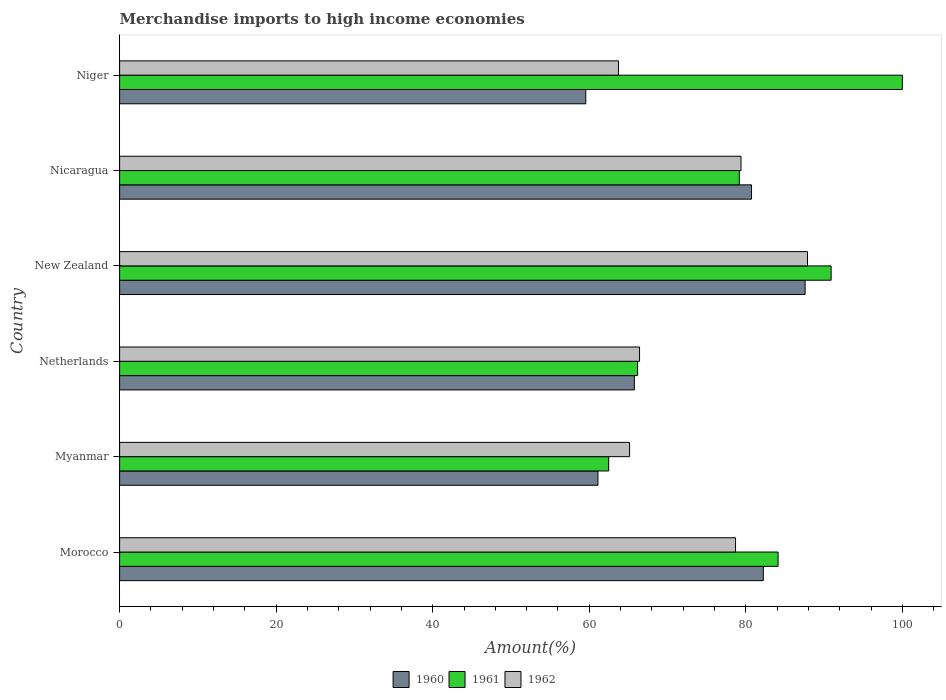How many different coloured bars are there?
Give a very brief answer. 3. Are the number of bars per tick equal to the number of legend labels?
Provide a succinct answer. Yes. How many bars are there on the 5th tick from the top?
Make the answer very short. 3. What is the label of the 2nd group of bars from the top?
Provide a succinct answer. Nicaragua. In how many cases, is the number of bars for a given country not equal to the number of legend labels?
Your answer should be compact. 0. What is the percentage of amount earned from merchandise imports in 1961 in Netherlands?
Make the answer very short. 66.17. Across all countries, what is the maximum percentage of amount earned from merchandise imports in 1960?
Provide a short and direct response. 87.58. Across all countries, what is the minimum percentage of amount earned from merchandise imports in 1961?
Give a very brief answer. 62.48. In which country was the percentage of amount earned from merchandise imports in 1960 maximum?
Ensure brevity in your answer.  New Zealand. In which country was the percentage of amount earned from merchandise imports in 1962 minimum?
Make the answer very short. Niger. What is the total percentage of amount earned from merchandise imports in 1961 in the graph?
Make the answer very short. 482.85. What is the difference between the percentage of amount earned from merchandise imports in 1962 in Morocco and that in Myanmar?
Provide a succinct answer. 13.54. What is the difference between the percentage of amount earned from merchandise imports in 1960 in New Zealand and the percentage of amount earned from merchandise imports in 1962 in Myanmar?
Give a very brief answer. 22.42. What is the average percentage of amount earned from merchandise imports in 1962 per country?
Ensure brevity in your answer.  73.55. What is the difference between the percentage of amount earned from merchandise imports in 1960 and percentage of amount earned from merchandise imports in 1961 in Netherlands?
Ensure brevity in your answer.  -0.41. In how many countries, is the percentage of amount earned from merchandise imports in 1962 greater than 44 %?
Provide a short and direct response. 6. What is the ratio of the percentage of amount earned from merchandise imports in 1962 in Myanmar to that in New Zealand?
Your response must be concise. 0.74. Is the percentage of amount earned from merchandise imports in 1962 in Netherlands less than that in New Zealand?
Offer a terse response. Yes. Is the difference between the percentage of amount earned from merchandise imports in 1960 in Myanmar and New Zealand greater than the difference between the percentage of amount earned from merchandise imports in 1961 in Myanmar and New Zealand?
Keep it short and to the point. Yes. What is the difference between the highest and the second highest percentage of amount earned from merchandise imports in 1960?
Provide a succinct answer. 5.34. What is the difference between the highest and the lowest percentage of amount earned from merchandise imports in 1960?
Make the answer very short. 28.02. In how many countries, is the percentage of amount earned from merchandise imports in 1962 greater than the average percentage of amount earned from merchandise imports in 1962 taken over all countries?
Your answer should be very brief. 3. Is the sum of the percentage of amount earned from merchandise imports in 1962 in Myanmar and Netherlands greater than the maximum percentage of amount earned from merchandise imports in 1961 across all countries?
Offer a very short reply. Yes. Is it the case that in every country, the sum of the percentage of amount earned from merchandise imports in 1960 and percentage of amount earned from merchandise imports in 1961 is greater than the percentage of amount earned from merchandise imports in 1962?
Provide a short and direct response. Yes. Are all the bars in the graph horizontal?
Make the answer very short. Yes. What is the difference between two consecutive major ticks on the X-axis?
Your answer should be very brief. 20. Are the values on the major ticks of X-axis written in scientific E-notation?
Your answer should be very brief. No. Does the graph contain grids?
Your response must be concise. No. How are the legend labels stacked?
Keep it short and to the point. Horizontal. What is the title of the graph?
Make the answer very short. Merchandise imports to high income economies. What is the label or title of the X-axis?
Offer a terse response. Amount(%). What is the Amount(%) in 1960 in Morocco?
Your response must be concise. 82.24. What is the Amount(%) in 1961 in Morocco?
Keep it short and to the point. 84.12. What is the Amount(%) of 1962 in Morocco?
Offer a terse response. 78.69. What is the Amount(%) of 1960 in Myanmar?
Your response must be concise. 61.11. What is the Amount(%) of 1961 in Myanmar?
Provide a succinct answer. 62.48. What is the Amount(%) in 1962 in Myanmar?
Offer a terse response. 65.15. What is the Amount(%) in 1960 in Netherlands?
Your response must be concise. 65.76. What is the Amount(%) in 1961 in Netherlands?
Provide a short and direct response. 66.17. What is the Amount(%) of 1962 in Netherlands?
Keep it short and to the point. 66.42. What is the Amount(%) in 1960 in New Zealand?
Give a very brief answer. 87.58. What is the Amount(%) of 1961 in New Zealand?
Ensure brevity in your answer.  90.9. What is the Amount(%) of 1962 in New Zealand?
Give a very brief answer. 87.88. What is the Amount(%) of 1960 in Nicaragua?
Ensure brevity in your answer.  80.73. What is the Amount(%) of 1961 in Nicaragua?
Keep it short and to the point. 79.17. What is the Amount(%) in 1962 in Nicaragua?
Your answer should be compact. 79.39. What is the Amount(%) of 1960 in Niger?
Make the answer very short. 59.56. What is the Amount(%) of 1961 in Niger?
Ensure brevity in your answer.  100. What is the Amount(%) of 1962 in Niger?
Make the answer very short. 63.74. Across all countries, what is the maximum Amount(%) in 1960?
Your answer should be very brief. 87.58. Across all countries, what is the maximum Amount(%) in 1962?
Make the answer very short. 87.88. Across all countries, what is the minimum Amount(%) in 1960?
Provide a succinct answer. 59.56. Across all countries, what is the minimum Amount(%) in 1961?
Keep it short and to the point. 62.48. Across all countries, what is the minimum Amount(%) in 1962?
Provide a short and direct response. 63.74. What is the total Amount(%) of 1960 in the graph?
Give a very brief answer. 436.97. What is the total Amount(%) of 1961 in the graph?
Provide a succinct answer. 482.85. What is the total Amount(%) in 1962 in the graph?
Your response must be concise. 441.27. What is the difference between the Amount(%) of 1960 in Morocco and that in Myanmar?
Ensure brevity in your answer.  21.12. What is the difference between the Amount(%) in 1961 in Morocco and that in Myanmar?
Your response must be concise. 21.64. What is the difference between the Amount(%) of 1962 in Morocco and that in Myanmar?
Provide a succinct answer. 13.54. What is the difference between the Amount(%) of 1960 in Morocco and that in Netherlands?
Your response must be concise. 16.48. What is the difference between the Amount(%) in 1961 in Morocco and that in Netherlands?
Provide a short and direct response. 17.95. What is the difference between the Amount(%) of 1962 in Morocco and that in Netherlands?
Provide a short and direct response. 12.27. What is the difference between the Amount(%) in 1960 in Morocco and that in New Zealand?
Your answer should be very brief. -5.34. What is the difference between the Amount(%) in 1961 in Morocco and that in New Zealand?
Provide a succinct answer. -6.78. What is the difference between the Amount(%) of 1962 in Morocco and that in New Zealand?
Your answer should be very brief. -9.19. What is the difference between the Amount(%) of 1960 in Morocco and that in Nicaragua?
Provide a succinct answer. 1.5. What is the difference between the Amount(%) of 1961 in Morocco and that in Nicaragua?
Offer a very short reply. 4.96. What is the difference between the Amount(%) of 1962 in Morocco and that in Nicaragua?
Provide a short and direct response. -0.7. What is the difference between the Amount(%) in 1960 in Morocco and that in Niger?
Your response must be concise. 22.68. What is the difference between the Amount(%) of 1961 in Morocco and that in Niger?
Offer a very short reply. -15.88. What is the difference between the Amount(%) in 1962 in Morocco and that in Niger?
Keep it short and to the point. 14.95. What is the difference between the Amount(%) in 1960 in Myanmar and that in Netherlands?
Offer a very short reply. -4.65. What is the difference between the Amount(%) of 1961 in Myanmar and that in Netherlands?
Ensure brevity in your answer.  -3.69. What is the difference between the Amount(%) in 1962 in Myanmar and that in Netherlands?
Ensure brevity in your answer.  -1.27. What is the difference between the Amount(%) in 1960 in Myanmar and that in New Zealand?
Offer a very short reply. -26.47. What is the difference between the Amount(%) of 1961 in Myanmar and that in New Zealand?
Provide a succinct answer. -28.42. What is the difference between the Amount(%) in 1962 in Myanmar and that in New Zealand?
Your answer should be compact. -22.73. What is the difference between the Amount(%) in 1960 in Myanmar and that in Nicaragua?
Keep it short and to the point. -19.62. What is the difference between the Amount(%) in 1961 in Myanmar and that in Nicaragua?
Keep it short and to the point. -16.68. What is the difference between the Amount(%) in 1962 in Myanmar and that in Nicaragua?
Provide a short and direct response. -14.23. What is the difference between the Amount(%) of 1960 in Myanmar and that in Niger?
Ensure brevity in your answer.  1.55. What is the difference between the Amount(%) of 1961 in Myanmar and that in Niger?
Keep it short and to the point. -37.52. What is the difference between the Amount(%) in 1962 in Myanmar and that in Niger?
Keep it short and to the point. 1.42. What is the difference between the Amount(%) in 1960 in Netherlands and that in New Zealand?
Ensure brevity in your answer.  -21.82. What is the difference between the Amount(%) in 1961 in Netherlands and that in New Zealand?
Your answer should be very brief. -24.73. What is the difference between the Amount(%) in 1962 in Netherlands and that in New Zealand?
Make the answer very short. -21.46. What is the difference between the Amount(%) in 1960 in Netherlands and that in Nicaragua?
Your response must be concise. -14.97. What is the difference between the Amount(%) in 1961 in Netherlands and that in Nicaragua?
Your answer should be compact. -12.99. What is the difference between the Amount(%) of 1962 in Netherlands and that in Nicaragua?
Offer a terse response. -12.96. What is the difference between the Amount(%) of 1960 in Netherlands and that in Niger?
Your response must be concise. 6.2. What is the difference between the Amount(%) in 1961 in Netherlands and that in Niger?
Provide a short and direct response. -33.83. What is the difference between the Amount(%) in 1962 in Netherlands and that in Niger?
Provide a short and direct response. 2.69. What is the difference between the Amount(%) in 1960 in New Zealand and that in Nicaragua?
Your answer should be compact. 6.85. What is the difference between the Amount(%) in 1961 in New Zealand and that in Nicaragua?
Your answer should be very brief. 11.73. What is the difference between the Amount(%) of 1962 in New Zealand and that in Nicaragua?
Your answer should be very brief. 8.49. What is the difference between the Amount(%) of 1960 in New Zealand and that in Niger?
Make the answer very short. 28.02. What is the difference between the Amount(%) of 1961 in New Zealand and that in Niger?
Offer a terse response. -9.1. What is the difference between the Amount(%) of 1962 in New Zealand and that in Niger?
Make the answer very short. 24.15. What is the difference between the Amount(%) in 1960 in Nicaragua and that in Niger?
Give a very brief answer. 21.17. What is the difference between the Amount(%) of 1961 in Nicaragua and that in Niger?
Offer a very short reply. -20.83. What is the difference between the Amount(%) in 1962 in Nicaragua and that in Niger?
Give a very brief answer. 15.65. What is the difference between the Amount(%) of 1960 in Morocco and the Amount(%) of 1961 in Myanmar?
Offer a very short reply. 19.75. What is the difference between the Amount(%) of 1960 in Morocco and the Amount(%) of 1962 in Myanmar?
Offer a very short reply. 17.08. What is the difference between the Amount(%) of 1961 in Morocco and the Amount(%) of 1962 in Myanmar?
Give a very brief answer. 18.97. What is the difference between the Amount(%) of 1960 in Morocco and the Amount(%) of 1961 in Netherlands?
Offer a very short reply. 16.06. What is the difference between the Amount(%) in 1960 in Morocco and the Amount(%) in 1962 in Netherlands?
Offer a terse response. 15.81. What is the difference between the Amount(%) in 1961 in Morocco and the Amount(%) in 1962 in Netherlands?
Provide a short and direct response. 17.7. What is the difference between the Amount(%) in 1960 in Morocco and the Amount(%) in 1961 in New Zealand?
Your answer should be compact. -8.66. What is the difference between the Amount(%) in 1960 in Morocco and the Amount(%) in 1962 in New Zealand?
Give a very brief answer. -5.65. What is the difference between the Amount(%) of 1961 in Morocco and the Amount(%) of 1962 in New Zealand?
Offer a terse response. -3.76. What is the difference between the Amount(%) of 1960 in Morocco and the Amount(%) of 1961 in Nicaragua?
Ensure brevity in your answer.  3.07. What is the difference between the Amount(%) in 1960 in Morocco and the Amount(%) in 1962 in Nicaragua?
Offer a very short reply. 2.85. What is the difference between the Amount(%) in 1961 in Morocco and the Amount(%) in 1962 in Nicaragua?
Offer a very short reply. 4.74. What is the difference between the Amount(%) of 1960 in Morocco and the Amount(%) of 1961 in Niger?
Offer a very short reply. -17.76. What is the difference between the Amount(%) in 1960 in Morocco and the Amount(%) in 1962 in Niger?
Your answer should be very brief. 18.5. What is the difference between the Amount(%) of 1961 in Morocco and the Amount(%) of 1962 in Niger?
Ensure brevity in your answer.  20.39. What is the difference between the Amount(%) in 1960 in Myanmar and the Amount(%) in 1961 in Netherlands?
Give a very brief answer. -5.06. What is the difference between the Amount(%) in 1960 in Myanmar and the Amount(%) in 1962 in Netherlands?
Your answer should be very brief. -5.31. What is the difference between the Amount(%) of 1961 in Myanmar and the Amount(%) of 1962 in Netherlands?
Ensure brevity in your answer.  -3.94. What is the difference between the Amount(%) of 1960 in Myanmar and the Amount(%) of 1961 in New Zealand?
Your answer should be very brief. -29.79. What is the difference between the Amount(%) in 1960 in Myanmar and the Amount(%) in 1962 in New Zealand?
Offer a terse response. -26.77. What is the difference between the Amount(%) in 1961 in Myanmar and the Amount(%) in 1962 in New Zealand?
Ensure brevity in your answer.  -25.4. What is the difference between the Amount(%) in 1960 in Myanmar and the Amount(%) in 1961 in Nicaragua?
Your response must be concise. -18.06. What is the difference between the Amount(%) of 1960 in Myanmar and the Amount(%) of 1962 in Nicaragua?
Ensure brevity in your answer.  -18.28. What is the difference between the Amount(%) in 1961 in Myanmar and the Amount(%) in 1962 in Nicaragua?
Offer a terse response. -16.91. What is the difference between the Amount(%) in 1960 in Myanmar and the Amount(%) in 1961 in Niger?
Your answer should be compact. -38.89. What is the difference between the Amount(%) of 1960 in Myanmar and the Amount(%) of 1962 in Niger?
Your answer should be very brief. -2.63. What is the difference between the Amount(%) of 1961 in Myanmar and the Amount(%) of 1962 in Niger?
Your response must be concise. -1.25. What is the difference between the Amount(%) in 1960 in Netherlands and the Amount(%) in 1961 in New Zealand?
Your response must be concise. -25.14. What is the difference between the Amount(%) in 1960 in Netherlands and the Amount(%) in 1962 in New Zealand?
Provide a succinct answer. -22.12. What is the difference between the Amount(%) of 1961 in Netherlands and the Amount(%) of 1962 in New Zealand?
Give a very brief answer. -21.71. What is the difference between the Amount(%) of 1960 in Netherlands and the Amount(%) of 1961 in Nicaragua?
Give a very brief answer. -13.41. What is the difference between the Amount(%) in 1960 in Netherlands and the Amount(%) in 1962 in Nicaragua?
Offer a terse response. -13.63. What is the difference between the Amount(%) in 1961 in Netherlands and the Amount(%) in 1962 in Nicaragua?
Make the answer very short. -13.21. What is the difference between the Amount(%) in 1960 in Netherlands and the Amount(%) in 1961 in Niger?
Your response must be concise. -34.24. What is the difference between the Amount(%) of 1960 in Netherlands and the Amount(%) of 1962 in Niger?
Your response must be concise. 2.02. What is the difference between the Amount(%) in 1961 in Netherlands and the Amount(%) in 1962 in Niger?
Offer a very short reply. 2.44. What is the difference between the Amount(%) of 1960 in New Zealand and the Amount(%) of 1961 in Nicaragua?
Provide a succinct answer. 8.41. What is the difference between the Amount(%) of 1960 in New Zealand and the Amount(%) of 1962 in Nicaragua?
Provide a short and direct response. 8.19. What is the difference between the Amount(%) of 1961 in New Zealand and the Amount(%) of 1962 in Nicaragua?
Provide a succinct answer. 11.51. What is the difference between the Amount(%) in 1960 in New Zealand and the Amount(%) in 1961 in Niger?
Give a very brief answer. -12.42. What is the difference between the Amount(%) in 1960 in New Zealand and the Amount(%) in 1962 in Niger?
Make the answer very short. 23.84. What is the difference between the Amount(%) of 1961 in New Zealand and the Amount(%) of 1962 in Niger?
Provide a succinct answer. 27.16. What is the difference between the Amount(%) in 1960 in Nicaragua and the Amount(%) in 1961 in Niger?
Offer a very short reply. -19.27. What is the difference between the Amount(%) of 1960 in Nicaragua and the Amount(%) of 1962 in Niger?
Provide a short and direct response. 17. What is the difference between the Amount(%) of 1961 in Nicaragua and the Amount(%) of 1962 in Niger?
Make the answer very short. 15.43. What is the average Amount(%) of 1960 per country?
Your response must be concise. 72.83. What is the average Amount(%) of 1961 per country?
Your answer should be compact. 80.47. What is the average Amount(%) of 1962 per country?
Provide a succinct answer. 73.55. What is the difference between the Amount(%) of 1960 and Amount(%) of 1961 in Morocco?
Offer a terse response. -1.89. What is the difference between the Amount(%) in 1960 and Amount(%) in 1962 in Morocco?
Your response must be concise. 3.54. What is the difference between the Amount(%) of 1961 and Amount(%) of 1962 in Morocco?
Make the answer very short. 5.43. What is the difference between the Amount(%) of 1960 and Amount(%) of 1961 in Myanmar?
Provide a succinct answer. -1.37. What is the difference between the Amount(%) of 1960 and Amount(%) of 1962 in Myanmar?
Your response must be concise. -4.04. What is the difference between the Amount(%) in 1961 and Amount(%) in 1962 in Myanmar?
Give a very brief answer. -2.67. What is the difference between the Amount(%) in 1960 and Amount(%) in 1961 in Netherlands?
Offer a very short reply. -0.41. What is the difference between the Amount(%) in 1960 and Amount(%) in 1962 in Netherlands?
Offer a very short reply. -0.66. What is the difference between the Amount(%) in 1961 and Amount(%) in 1962 in Netherlands?
Your response must be concise. -0.25. What is the difference between the Amount(%) of 1960 and Amount(%) of 1961 in New Zealand?
Your answer should be compact. -3.32. What is the difference between the Amount(%) in 1960 and Amount(%) in 1962 in New Zealand?
Your answer should be compact. -0.3. What is the difference between the Amount(%) of 1961 and Amount(%) of 1962 in New Zealand?
Your response must be concise. 3.02. What is the difference between the Amount(%) in 1960 and Amount(%) in 1961 in Nicaragua?
Provide a short and direct response. 1.56. What is the difference between the Amount(%) in 1960 and Amount(%) in 1962 in Nicaragua?
Offer a very short reply. 1.34. What is the difference between the Amount(%) in 1961 and Amount(%) in 1962 in Nicaragua?
Offer a terse response. -0.22. What is the difference between the Amount(%) of 1960 and Amount(%) of 1961 in Niger?
Your response must be concise. -40.44. What is the difference between the Amount(%) of 1960 and Amount(%) of 1962 in Niger?
Offer a very short reply. -4.18. What is the difference between the Amount(%) of 1961 and Amount(%) of 1962 in Niger?
Give a very brief answer. 36.26. What is the ratio of the Amount(%) of 1960 in Morocco to that in Myanmar?
Keep it short and to the point. 1.35. What is the ratio of the Amount(%) in 1961 in Morocco to that in Myanmar?
Your answer should be very brief. 1.35. What is the ratio of the Amount(%) in 1962 in Morocco to that in Myanmar?
Give a very brief answer. 1.21. What is the ratio of the Amount(%) of 1960 in Morocco to that in Netherlands?
Make the answer very short. 1.25. What is the ratio of the Amount(%) in 1961 in Morocco to that in Netherlands?
Ensure brevity in your answer.  1.27. What is the ratio of the Amount(%) of 1962 in Morocco to that in Netherlands?
Offer a terse response. 1.18. What is the ratio of the Amount(%) in 1960 in Morocco to that in New Zealand?
Provide a succinct answer. 0.94. What is the ratio of the Amount(%) in 1961 in Morocco to that in New Zealand?
Give a very brief answer. 0.93. What is the ratio of the Amount(%) of 1962 in Morocco to that in New Zealand?
Offer a very short reply. 0.9. What is the ratio of the Amount(%) of 1960 in Morocco to that in Nicaragua?
Your answer should be very brief. 1.02. What is the ratio of the Amount(%) in 1961 in Morocco to that in Nicaragua?
Offer a very short reply. 1.06. What is the ratio of the Amount(%) in 1960 in Morocco to that in Niger?
Your response must be concise. 1.38. What is the ratio of the Amount(%) in 1961 in Morocco to that in Niger?
Provide a short and direct response. 0.84. What is the ratio of the Amount(%) of 1962 in Morocco to that in Niger?
Offer a very short reply. 1.23. What is the ratio of the Amount(%) in 1960 in Myanmar to that in Netherlands?
Offer a very short reply. 0.93. What is the ratio of the Amount(%) of 1961 in Myanmar to that in Netherlands?
Offer a very short reply. 0.94. What is the ratio of the Amount(%) in 1962 in Myanmar to that in Netherlands?
Offer a very short reply. 0.98. What is the ratio of the Amount(%) in 1960 in Myanmar to that in New Zealand?
Keep it short and to the point. 0.7. What is the ratio of the Amount(%) of 1961 in Myanmar to that in New Zealand?
Provide a short and direct response. 0.69. What is the ratio of the Amount(%) of 1962 in Myanmar to that in New Zealand?
Keep it short and to the point. 0.74. What is the ratio of the Amount(%) in 1960 in Myanmar to that in Nicaragua?
Make the answer very short. 0.76. What is the ratio of the Amount(%) of 1961 in Myanmar to that in Nicaragua?
Provide a short and direct response. 0.79. What is the ratio of the Amount(%) in 1962 in Myanmar to that in Nicaragua?
Offer a terse response. 0.82. What is the ratio of the Amount(%) of 1960 in Myanmar to that in Niger?
Provide a succinct answer. 1.03. What is the ratio of the Amount(%) in 1961 in Myanmar to that in Niger?
Make the answer very short. 0.62. What is the ratio of the Amount(%) in 1962 in Myanmar to that in Niger?
Make the answer very short. 1.02. What is the ratio of the Amount(%) of 1960 in Netherlands to that in New Zealand?
Ensure brevity in your answer.  0.75. What is the ratio of the Amount(%) in 1961 in Netherlands to that in New Zealand?
Provide a short and direct response. 0.73. What is the ratio of the Amount(%) of 1962 in Netherlands to that in New Zealand?
Offer a terse response. 0.76. What is the ratio of the Amount(%) of 1960 in Netherlands to that in Nicaragua?
Ensure brevity in your answer.  0.81. What is the ratio of the Amount(%) in 1961 in Netherlands to that in Nicaragua?
Offer a very short reply. 0.84. What is the ratio of the Amount(%) in 1962 in Netherlands to that in Nicaragua?
Offer a terse response. 0.84. What is the ratio of the Amount(%) in 1960 in Netherlands to that in Niger?
Your response must be concise. 1.1. What is the ratio of the Amount(%) of 1961 in Netherlands to that in Niger?
Give a very brief answer. 0.66. What is the ratio of the Amount(%) of 1962 in Netherlands to that in Niger?
Your answer should be compact. 1.04. What is the ratio of the Amount(%) in 1960 in New Zealand to that in Nicaragua?
Offer a terse response. 1.08. What is the ratio of the Amount(%) of 1961 in New Zealand to that in Nicaragua?
Provide a short and direct response. 1.15. What is the ratio of the Amount(%) of 1962 in New Zealand to that in Nicaragua?
Your answer should be very brief. 1.11. What is the ratio of the Amount(%) of 1960 in New Zealand to that in Niger?
Your response must be concise. 1.47. What is the ratio of the Amount(%) in 1961 in New Zealand to that in Niger?
Offer a terse response. 0.91. What is the ratio of the Amount(%) of 1962 in New Zealand to that in Niger?
Keep it short and to the point. 1.38. What is the ratio of the Amount(%) in 1960 in Nicaragua to that in Niger?
Give a very brief answer. 1.36. What is the ratio of the Amount(%) of 1961 in Nicaragua to that in Niger?
Make the answer very short. 0.79. What is the ratio of the Amount(%) of 1962 in Nicaragua to that in Niger?
Your answer should be compact. 1.25. What is the difference between the highest and the second highest Amount(%) in 1960?
Provide a short and direct response. 5.34. What is the difference between the highest and the second highest Amount(%) of 1961?
Your answer should be very brief. 9.1. What is the difference between the highest and the second highest Amount(%) in 1962?
Offer a very short reply. 8.49. What is the difference between the highest and the lowest Amount(%) in 1960?
Keep it short and to the point. 28.02. What is the difference between the highest and the lowest Amount(%) of 1961?
Keep it short and to the point. 37.52. What is the difference between the highest and the lowest Amount(%) of 1962?
Provide a succinct answer. 24.15. 